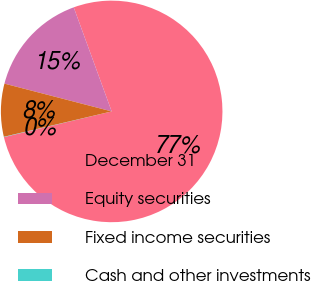Convert chart to OTSL. <chart><loc_0><loc_0><loc_500><loc_500><pie_chart><fcel>December 31<fcel>Equity securities<fcel>Fixed income securities<fcel>Cash and other investments<nl><fcel>76.84%<fcel>15.4%<fcel>7.72%<fcel>0.04%<nl></chart> 